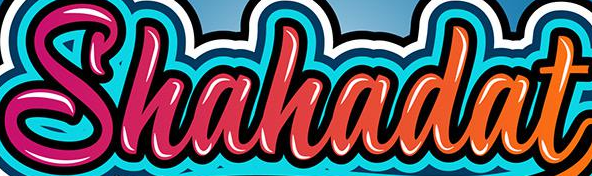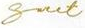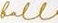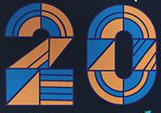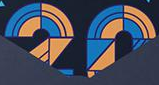What words can you see in these images in sequence, separated by a semicolon? Shahadat; Snet; foll; 20; 20 